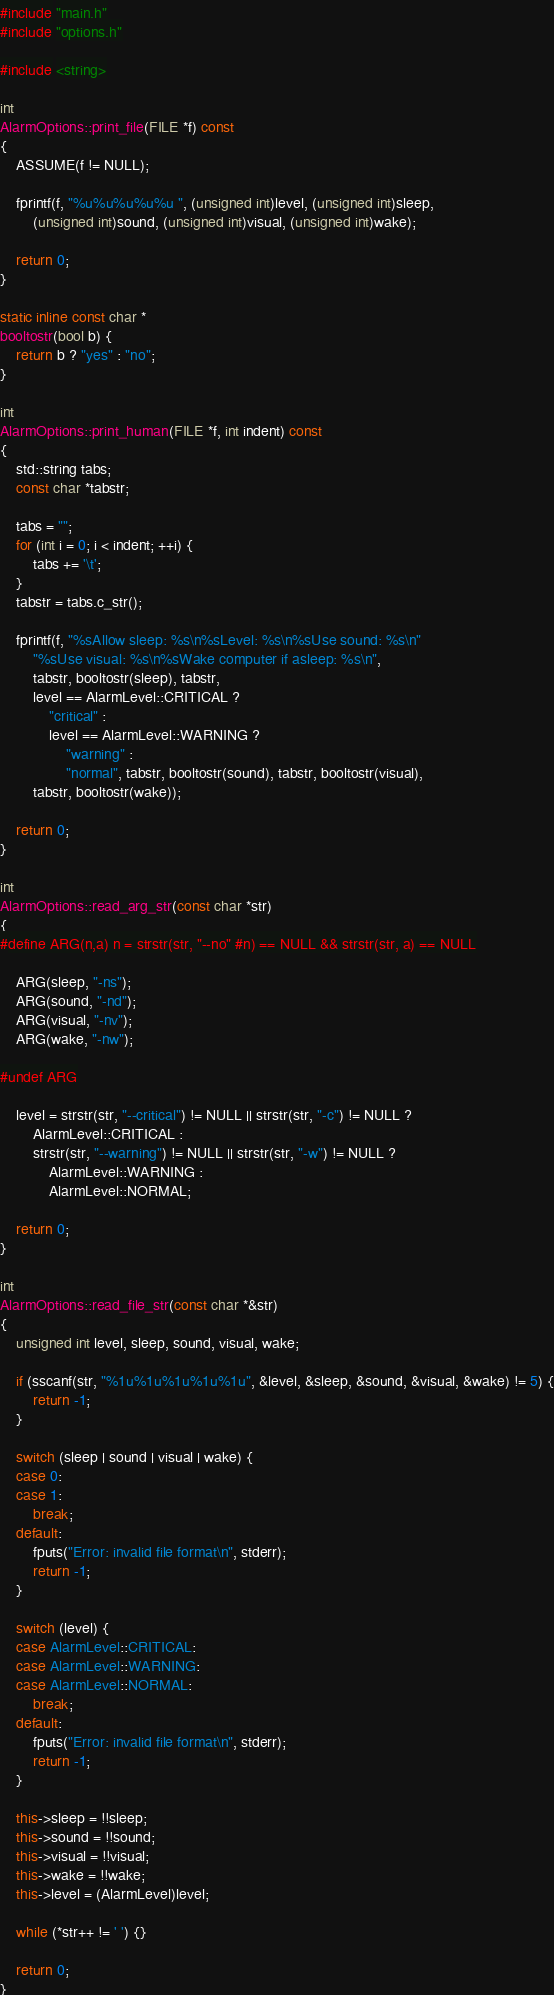<code> <loc_0><loc_0><loc_500><loc_500><_C++_>#include "main.h"
#include "options.h"

#include <string>

int
AlarmOptions::print_file(FILE *f) const
{
	ASSUME(f != NULL);

	fprintf(f, "%u%u%u%u%u ", (unsigned int)level, (unsigned int)sleep,
		(unsigned int)sound, (unsigned int)visual, (unsigned int)wake);

	return 0;
}

static inline const char *
booltostr(bool b) {
	return b ? "yes" : "no";
}

int
AlarmOptions::print_human(FILE *f, int indent) const
{
	std::string tabs;
	const char *tabstr;
	
	tabs = "";
	for (int i = 0; i < indent; ++i) {
		tabs += '\t';
	}
	tabstr = tabs.c_str();

	fprintf(f, "%sAllow sleep: %s\n%sLevel: %s\n%sUse sound: %s\n"
		"%sUse visual: %s\n%sWake computer if asleep: %s\n",
		tabstr, booltostr(sleep), tabstr,
		level == AlarmLevel::CRITICAL ?
			"critical" :
			level == AlarmLevel::WARNING ?
				"warning" :
				"normal", tabstr, booltostr(sound), tabstr, booltostr(visual),
		tabstr, booltostr(wake));

	return 0;
}

int
AlarmOptions::read_arg_str(const char *str)
{
#define ARG(n,a) n = strstr(str, "--no" #n) == NULL && strstr(str, a) == NULL

	ARG(sleep, "-ns");
	ARG(sound, "-nd");
	ARG(visual, "-nv");
	ARG(wake, "-nw");

#undef ARG

	level = strstr(str, "--critical") != NULL || strstr(str, "-c") != NULL ?
		AlarmLevel::CRITICAL :
		strstr(str, "--warning") != NULL || strstr(str, "-w") != NULL ?
			AlarmLevel::WARNING :
			AlarmLevel::NORMAL;

	return 0;
}

int
AlarmOptions::read_file_str(const char *&str)
{
	unsigned int level, sleep, sound, visual, wake;

	if (sscanf(str, "%1u%1u%1u%1u%1u", &level, &sleep, &sound, &visual, &wake) != 5) {
		return -1;
	}

	switch (sleep | sound | visual | wake) {
	case 0:
	case 1:
		break;
	default:
		fputs("Error: invalid file format\n", stderr);
		return -1;
	}

	switch (level) {
	case AlarmLevel::CRITICAL:
	case AlarmLevel::WARNING:
	case AlarmLevel::NORMAL:
		break;
	default:
		fputs("Error: invalid file format\n", stderr);
		return -1;
	}

	this->sleep = !!sleep;
	this->sound = !!sound;
	this->visual = !!visual;
	this->wake = !!wake;
	this->level = (AlarmLevel)level;

	while (*str++ != ' ') {}

	return 0;
}</code> 